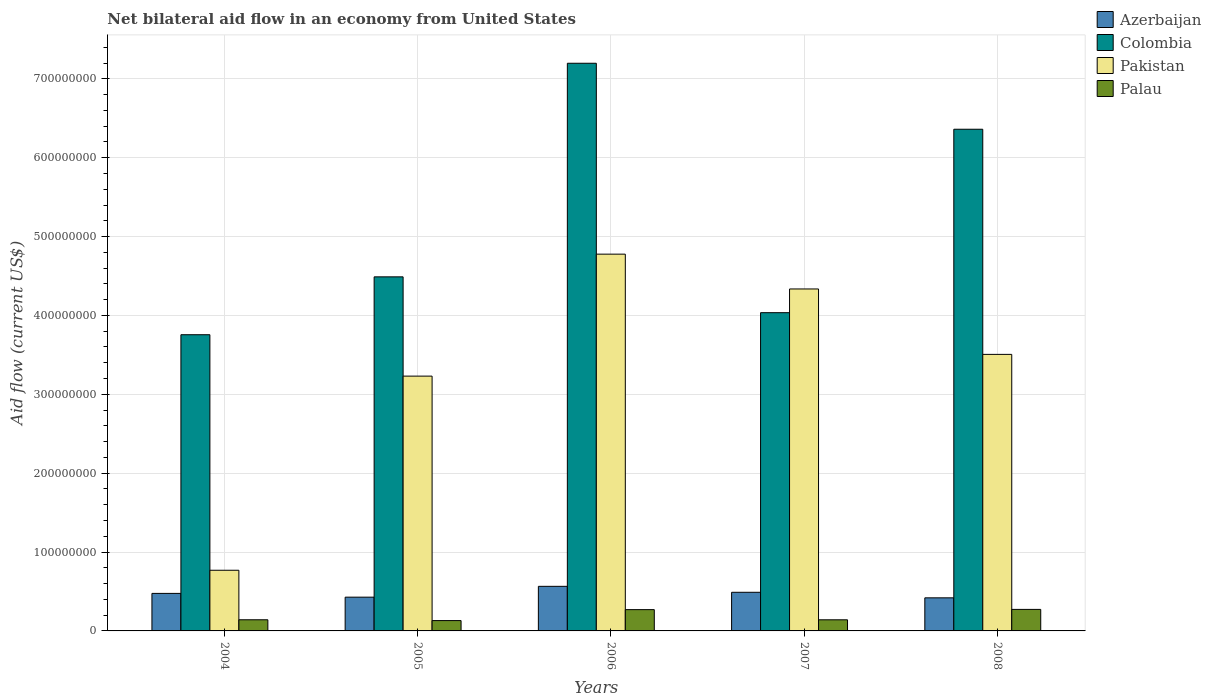How many groups of bars are there?
Your answer should be very brief. 5. How many bars are there on the 5th tick from the left?
Your answer should be compact. 4. How many bars are there on the 2nd tick from the right?
Provide a succinct answer. 4. What is the label of the 1st group of bars from the left?
Provide a short and direct response. 2004. What is the net bilateral aid flow in Colombia in 2004?
Your answer should be compact. 3.76e+08. Across all years, what is the maximum net bilateral aid flow in Palau?
Your answer should be compact. 2.73e+07. Across all years, what is the minimum net bilateral aid flow in Colombia?
Offer a terse response. 3.76e+08. What is the total net bilateral aid flow in Palau in the graph?
Provide a short and direct response. 9.56e+07. What is the difference between the net bilateral aid flow in Pakistan in 2004 and that in 2008?
Your answer should be very brief. -2.74e+08. What is the difference between the net bilateral aid flow in Azerbaijan in 2006 and the net bilateral aid flow in Colombia in 2004?
Provide a short and direct response. -3.19e+08. What is the average net bilateral aid flow in Azerbaijan per year?
Offer a terse response. 4.76e+07. In the year 2004, what is the difference between the net bilateral aid flow in Palau and net bilateral aid flow in Colombia?
Offer a very short reply. -3.61e+08. In how many years, is the net bilateral aid flow in Palau greater than 60000000 US$?
Provide a short and direct response. 0. What is the ratio of the net bilateral aid flow in Palau in 2006 to that in 2008?
Provide a short and direct response. 0.99. Is the net bilateral aid flow in Azerbaijan in 2004 less than that in 2007?
Your response must be concise. Yes. What is the difference between the highest and the second highest net bilateral aid flow in Pakistan?
Your response must be concise. 4.42e+07. What is the difference between the highest and the lowest net bilateral aid flow in Colombia?
Your answer should be very brief. 3.44e+08. In how many years, is the net bilateral aid flow in Pakistan greater than the average net bilateral aid flow in Pakistan taken over all years?
Give a very brief answer. 3. Is the sum of the net bilateral aid flow in Pakistan in 2004 and 2008 greater than the maximum net bilateral aid flow in Palau across all years?
Ensure brevity in your answer.  Yes. What does the 1st bar from the left in 2008 represents?
Ensure brevity in your answer.  Azerbaijan. What does the 4th bar from the right in 2008 represents?
Provide a short and direct response. Azerbaijan. Is it the case that in every year, the sum of the net bilateral aid flow in Palau and net bilateral aid flow in Pakistan is greater than the net bilateral aid flow in Azerbaijan?
Your answer should be very brief. Yes. How many bars are there?
Your answer should be very brief. 20. Are all the bars in the graph horizontal?
Your answer should be compact. No. Does the graph contain any zero values?
Offer a terse response. No. Where does the legend appear in the graph?
Offer a terse response. Top right. How many legend labels are there?
Keep it short and to the point. 4. How are the legend labels stacked?
Your response must be concise. Vertical. What is the title of the graph?
Make the answer very short. Net bilateral aid flow in an economy from United States. Does "Cabo Verde" appear as one of the legend labels in the graph?
Make the answer very short. No. What is the label or title of the Y-axis?
Keep it short and to the point. Aid flow (current US$). What is the Aid flow (current US$) in Azerbaijan in 2004?
Provide a short and direct response. 4.76e+07. What is the Aid flow (current US$) of Colombia in 2004?
Your answer should be very brief. 3.76e+08. What is the Aid flow (current US$) of Pakistan in 2004?
Make the answer very short. 7.69e+07. What is the Aid flow (current US$) of Palau in 2004?
Ensure brevity in your answer.  1.41e+07. What is the Aid flow (current US$) of Azerbaijan in 2005?
Give a very brief answer. 4.28e+07. What is the Aid flow (current US$) in Colombia in 2005?
Your answer should be compact. 4.49e+08. What is the Aid flow (current US$) in Pakistan in 2005?
Provide a short and direct response. 3.23e+08. What is the Aid flow (current US$) in Palau in 2005?
Your answer should be very brief. 1.31e+07. What is the Aid flow (current US$) in Azerbaijan in 2006?
Offer a terse response. 5.65e+07. What is the Aid flow (current US$) of Colombia in 2006?
Make the answer very short. 7.20e+08. What is the Aid flow (current US$) of Pakistan in 2006?
Give a very brief answer. 4.78e+08. What is the Aid flow (current US$) of Palau in 2006?
Your response must be concise. 2.70e+07. What is the Aid flow (current US$) in Azerbaijan in 2007?
Make the answer very short. 4.90e+07. What is the Aid flow (current US$) of Colombia in 2007?
Your response must be concise. 4.04e+08. What is the Aid flow (current US$) of Pakistan in 2007?
Your answer should be very brief. 4.34e+08. What is the Aid flow (current US$) in Palau in 2007?
Offer a terse response. 1.41e+07. What is the Aid flow (current US$) of Azerbaijan in 2008?
Your answer should be very brief. 4.20e+07. What is the Aid flow (current US$) of Colombia in 2008?
Offer a very short reply. 6.36e+08. What is the Aid flow (current US$) in Pakistan in 2008?
Offer a terse response. 3.51e+08. What is the Aid flow (current US$) in Palau in 2008?
Provide a succinct answer. 2.73e+07. Across all years, what is the maximum Aid flow (current US$) of Azerbaijan?
Give a very brief answer. 5.65e+07. Across all years, what is the maximum Aid flow (current US$) of Colombia?
Offer a terse response. 7.20e+08. Across all years, what is the maximum Aid flow (current US$) of Pakistan?
Your answer should be very brief. 4.78e+08. Across all years, what is the maximum Aid flow (current US$) of Palau?
Make the answer very short. 2.73e+07. Across all years, what is the minimum Aid flow (current US$) in Azerbaijan?
Offer a terse response. 4.20e+07. Across all years, what is the minimum Aid flow (current US$) of Colombia?
Give a very brief answer. 3.76e+08. Across all years, what is the minimum Aid flow (current US$) in Pakistan?
Offer a terse response. 7.69e+07. Across all years, what is the minimum Aid flow (current US$) in Palau?
Offer a terse response. 1.31e+07. What is the total Aid flow (current US$) of Azerbaijan in the graph?
Ensure brevity in your answer.  2.38e+08. What is the total Aid flow (current US$) in Colombia in the graph?
Provide a short and direct response. 2.58e+09. What is the total Aid flow (current US$) in Pakistan in the graph?
Keep it short and to the point. 1.66e+09. What is the total Aid flow (current US$) in Palau in the graph?
Provide a short and direct response. 9.56e+07. What is the difference between the Aid flow (current US$) in Azerbaijan in 2004 and that in 2005?
Provide a succinct answer. 4.78e+06. What is the difference between the Aid flow (current US$) of Colombia in 2004 and that in 2005?
Make the answer very short. -7.34e+07. What is the difference between the Aid flow (current US$) in Pakistan in 2004 and that in 2005?
Provide a succinct answer. -2.46e+08. What is the difference between the Aid flow (current US$) in Palau in 2004 and that in 2005?
Offer a very short reply. 1.04e+06. What is the difference between the Aid flow (current US$) of Azerbaijan in 2004 and that in 2006?
Your answer should be compact. -8.96e+06. What is the difference between the Aid flow (current US$) in Colombia in 2004 and that in 2006?
Keep it short and to the point. -3.44e+08. What is the difference between the Aid flow (current US$) of Pakistan in 2004 and that in 2006?
Your answer should be very brief. -4.01e+08. What is the difference between the Aid flow (current US$) of Palau in 2004 and that in 2006?
Offer a terse response. -1.29e+07. What is the difference between the Aid flow (current US$) of Azerbaijan in 2004 and that in 2007?
Keep it short and to the point. -1.40e+06. What is the difference between the Aid flow (current US$) of Colombia in 2004 and that in 2007?
Offer a very short reply. -2.79e+07. What is the difference between the Aid flow (current US$) of Pakistan in 2004 and that in 2007?
Your answer should be very brief. -3.57e+08. What is the difference between the Aid flow (current US$) of Palau in 2004 and that in 2007?
Ensure brevity in your answer.  4.00e+04. What is the difference between the Aid flow (current US$) of Azerbaijan in 2004 and that in 2008?
Your answer should be compact. 5.63e+06. What is the difference between the Aid flow (current US$) in Colombia in 2004 and that in 2008?
Your response must be concise. -2.61e+08. What is the difference between the Aid flow (current US$) in Pakistan in 2004 and that in 2008?
Your response must be concise. -2.74e+08. What is the difference between the Aid flow (current US$) of Palau in 2004 and that in 2008?
Ensure brevity in your answer.  -1.32e+07. What is the difference between the Aid flow (current US$) in Azerbaijan in 2005 and that in 2006?
Provide a succinct answer. -1.37e+07. What is the difference between the Aid flow (current US$) in Colombia in 2005 and that in 2006?
Offer a very short reply. -2.71e+08. What is the difference between the Aid flow (current US$) of Pakistan in 2005 and that in 2006?
Give a very brief answer. -1.55e+08. What is the difference between the Aid flow (current US$) of Palau in 2005 and that in 2006?
Your response must be concise. -1.39e+07. What is the difference between the Aid flow (current US$) in Azerbaijan in 2005 and that in 2007?
Your response must be concise. -6.18e+06. What is the difference between the Aid flow (current US$) of Colombia in 2005 and that in 2007?
Ensure brevity in your answer.  4.54e+07. What is the difference between the Aid flow (current US$) in Pakistan in 2005 and that in 2007?
Ensure brevity in your answer.  -1.10e+08. What is the difference between the Aid flow (current US$) of Azerbaijan in 2005 and that in 2008?
Offer a very short reply. 8.50e+05. What is the difference between the Aid flow (current US$) of Colombia in 2005 and that in 2008?
Your answer should be compact. -1.87e+08. What is the difference between the Aid flow (current US$) of Pakistan in 2005 and that in 2008?
Your answer should be very brief. -2.76e+07. What is the difference between the Aid flow (current US$) of Palau in 2005 and that in 2008?
Provide a short and direct response. -1.42e+07. What is the difference between the Aid flow (current US$) in Azerbaijan in 2006 and that in 2007?
Your answer should be compact. 7.56e+06. What is the difference between the Aid flow (current US$) of Colombia in 2006 and that in 2007?
Your response must be concise. 3.16e+08. What is the difference between the Aid flow (current US$) in Pakistan in 2006 and that in 2007?
Keep it short and to the point. 4.42e+07. What is the difference between the Aid flow (current US$) in Palau in 2006 and that in 2007?
Make the answer very short. 1.29e+07. What is the difference between the Aid flow (current US$) of Azerbaijan in 2006 and that in 2008?
Offer a terse response. 1.46e+07. What is the difference between the Aid flow (current US$) of Colombia in 2006 and that in 2008?
Your response must be concise. 8.37e+07. What is the difference between the Aid flow (current US$) of Pakistan in 2006 and that in 2008?
Your response must be concise. 1.27e+08. What is the difference between the Aid flow (current US$) of Palau in 2006 and that in 2008?
Provide a short and direct response. -2.90e+05. What is the difference between the Aid flow (current US$) of Azerbaijan in 2007 and that in 2008?
Offer a very short reply. 7.03e+06. What is the difference between the Aid flow (current US$) of Colombia in 2007 and that in 2008?
Provide a short and direct response. -2.33e+08. What is the difference between the Aid flow (current US$) of Pakistan in 2007 and that in 2008?
Provide a short and direct response. 8.29e+07. What is the difference between the Aid flow (current US$) of Palau in 2007 and that in 2008?
Give a very brief answer. -1.32e+07. What is the difference between the Aid flow (current US$) in Azerbaijan in 2004 and the Aid flow (current US$) in Colombia in 2005?
Provide a succinct answer. -4.01e+08. What is the difference between the Aid flow (current US$) in Azerbaijan in 2004 and the Aid flow (current US$) in Pakistan in 2005?
Keep it short and to the point. -2.75e+08. What is the difference between the Aid flow (current US$) in Azerbaijan in 2004 and the Aid flow (current US$) in Palau in 2005?
Offer a terse response. 3.45e+07. What is the difference between the Aid flow (current US$) in Colombia in 2004 and the Aid flow (current US$) in Pakistan in 2005?
Provide a short and direct response. 5.25e+07. What is the difference between the Aid flow (current US$) in Colombia in 2004 and the Aid flow (current US$) in Palau in 2005?
Offer a very short reply. 3.62e+08. What is the difference between the Aid flow (current US$) in Pakistan in 2004 and the Aid flow (current US$) in Palau in 2005?
Ensure brevity in your answer.  6.38e+07. What is the difference between the Aid flow (current US$) of Azerbaijan in 2004 and the Aid flow (current US$) of Colombia in 2006?
Your answer should be compact. -6.72e+08. What is the difference between the Aid flow (current US$) of Azerbaijan in 2004 and the Aid flow (current US$) of Pakistan in 2006?
Provide a short and direct response. -4.30e+08. What is the difference between the Aid flow (current US$) in Azerbaijan in 2004 and the Aid flow (current US$) in Palau in 2006?
Provide a short and direct response. 2.06e+07. What is the difference between the Aid flow (current US$) of Colombia in 2004 and the Aid flow (current US$) of Pakistan in 2006?
Provide a succinct answer. -1.02e+08. What is the difference between the Aid flow (current US$) of Colombia in 2004 and the Aid flow (current US$) of Palau in 2006?
Keep it short and to the point. 3.49e+08. What is the difference between the Aid flow (current US$) in Pakistan in 2004 and the Aid flow (current US$) in Palau in 2006?
Your answer should be very brief. 4.99e+07. What is the difference between the Aid flow (current US$) of Azerbaijan in 2004 and the Aid flow (current US$) of Colombia in 2007?
Your answer should be compact. -3.56e+08. What is the difference between the Aid flow (current US$) in Azerbaijan in 2004 and the Aid flow (current US$) in Pakistan in 2007?
Keep it short and to the point. -3.86e+08. What is the difference between the Aid flow (current US$) of Azerbaijan in 2004 and the Aid flow (current US$) of Palau in 2007?
Provide a short and direct response. 3.35e+07. What is the difference between the Aid flow (current US$) of Colombia in 2004 and the Aid flow (current US$) of Pakistan in 2007?
Provide a short and direct response. -5.80e+07. What is the difference between the Aid flow (current US$) of Colombia in 2004 and the Aid flow (current US$) of Palau in 2007?
Your response must be concise. 3.61e+08. What is the difference between the Aid flow (current US$) in Pakistan in 2004 and the Aid flow (current US$) in Palau in 2007?
Your answer should be compact. 6.28e+07. What is the difference between the Aid flow (current US$) in Azerbaijan in 2004 and the Aid flow (current US$) in Colombia in 2008?
Ensure brevity in your answer.  -5.89e+08. What is the difference between the Aid flow (current US$) of Azerbaijan in 2004 and the Aid flow (current US$) of Pakistan in 2008?
Give a very brief answer. -3.03e+08. What is the difference between the Aid flow (current US$) of Azerbaijan in 2004 and the Aid flow (current US$) of Palau in 2008?
Give a very brief answer. 2.03e+07. What is the difference between the Aid flow (current US$) of Colombia in 2004 and the Aid flow (current US$) of Pakistan in 2008?
Make the answer very short. 2.49e+07. What is the difference between the Aid flow (current US$) in Colombia in 2004 and the Aid flow (current US$) in Palau in 2008?
Offer a terse response. 3.48e+08. What is the difference between the Aid flow (current US$) in Pakistan in 2004 and the Aid flow (current US$) in Palau in 2008?
Ensure brevity in your answer.  4.96e+07. What is the difference between the Aid flow (current US$) in Azerbaijan in 2005 and the Aid flow (current US$) in Colombia in 2006?
Provide a short and direct response. -6.77e+08. What is the difference between the Aid flow (current US$) of Azerbaijan in 2005 and the Aid flow (current US$) of Pakistan in 2006?
Provide a short and direct response. -4.35e+08. What is the difference between the Aid flow (current US$) in Azerbaijan in 2005 and the Aid flow (current US$) in Palau in 2006?
Provide a short and direct response. 1.58e+07. What is the difference between the Aid flow (current US$) in Colombia in 2005 and the Aid flow (current US$) in Pakistan in 2006?
Offer a terse response. -2.88e+07. What is the difference between the Aid flow (current US$) in Colombia in 2005 and the Aid flow (current US$) in Palau in 2006?
Ensure brevity in your answer.  4.22e+08. What is the difference between the Aid flow (current US$) in Pakistan in 2005 and the Aid flow (current US$) in Palau in 2006?
Offer a terse response. 2.96e+08. What is the difference between the Aid flow (current US$) of Azerbaijan in 2005 and the Aid flow (current US$) of Colombia in 2007?
Keep it short and to the point. -3.61e+08. What is the difference between the Aid flow (current US$) of Azerbaijan in 2005 and the Aid flow (current US$) of Pakistan in 2007?
Make the answer very short. -3.91e+08. What is the difference between the Aid flow (current US$) of Azerbaijan in 2005 and the Aid flow (current US$) of Palau in 2007?
Your answer should be compact. 2.87e+07. What is the difference between the Aid flow (current US$) of Colombia in 2005 and the Aid flow (current US$) of Pakistan in 2007?
Your response must be concise. 1.54e+07. What is the difference between the Aid flow (current US$) of Colombia in 2005 and the Aid flow (current US$) of Palau in 2007?
Your response must be concise. 4.35e+08. What is the difference between the Aid flow (current US$) in Pakistan in 2005 and the Aid flow (current US$) in Palau in 2007?
Ensure brevity in your answer.  3.09e+08. What is the difference between the Aid flow (current US$) of Azerbaijan in 2005 and the Aid flow (current US$) of Colombia in 2008?
Ensure brevity in your answer.  -5.93e+08. What is the difference between the Aid flow (current US$) in Azerbaijan in 2005 and the Aid flow (current US$) in Pakistan in 2008?
Provide a short and direct response. -3.08e+08. What is the difference between the Aid flow (current US$) in Azerbaijan in 2005 and the Aid flow (current US$) in Palau in 2008?
Ensure brevity in your answer.  1.55e+07. What is the difference between the Aid flow (current US$) of Colombia in 2005 and the Aid flow (current US$) of Pakistan in 2008?
Make the answer very short. 9.83e+07. What is the difference between the Aid flow (current US$) in Colombia in 2005 and the Aid flow (current US$) in Palau in 2008?
Your answer should be compact. 4.22e+08. What is the difference between the Aid flow (current US$) in Pakistan in 2005 and the Aid flow (current US$) in Palau in 2008?
Offer a terse response. 2.96e+08. What is the difference between the Aid flow (current US$) in Azerbaijan in 2006 and the Aid flow (current US$) in Colombia in 2007?
Make the answer very short. -3.47e+08. What is the difference between the Aid flow (current US$) of Azerbaijan in 2006 and the Aid flow (current US$) of Pakistan in 2007?
Keep it short and to the point. -3.77e+08. What is the difference between the Aid flow (current US$) of Azerbaijan in 2006 and the Aid flow (current US$) of Palau in 2007?
Your response must be concise. 4.24e+07. What is the difference between the Aid flow (current US$) in Colombia in 2006 and the Aid flow (current US$) in Pakistan in 2007?
Provide a succinct answer. 2.86e+08. What is the difference between the Aid flow (current US$) in Colombia in 2006 and the Aid flow (current US$) in Palau in 2007?
Provide a short and direct response. 7.06e+08. What is the difference between the Aid flow (current US$) of Pakistan in 2006 and the Aid flow (current US$) of Palau in 2007?
Your answer should be compact. 4.64e+08. What is the difference between the Aid flow (current US$) of Azerbaijan in 2006 and the Aid flow (current US$) of Colombia in 2008?
Keep it short and to the point. -5.80e+08. What is the difference between the Aid flow (current US$) of Azerbaijan in 2006 and the Aid flow (current US$) of Pakistan in 2008?
Your response must be concise. -2.94e+08. What is the difference between the Aid flow (current US$) of Azerbaijan in 2006 and the Aid flow (current US$) of Palau in 2008?
Give a very brief answer. 2.92e+07. What is the difference between the Aid flow (current US$) of Colombia in 2006 and the Aid flow (current US$) of Pakistan in 2008?
Make the answer very short. 3.69e+08. What is the difference between the Aid flow (current US$) in Colombia in 2006 and the Aid flow (current US$) in Palau in 2008?
Provide a short and direct response. 6.92e+08. What is the difference between the Aid flow (current US$) in Pakistan in 2006 and the Aid flow (current US$) in Palau in 2008?
Make the answer very short. 4.50e+08. What is the difference between the Aid flow (current US$) in Azerbaijan in 2007 and the Aid flow (current US$) in Colombia in 2008?
Your response must be concise. -5.87e+08. What is the difference between the Aid flow (current US$) of Azerbaijan in 2007 and the Aid flow (current US$) of Pakistan in 2008?
Ensure brevity in your answer.  -3.02e+08. What is the difference between the Aid flow (current US$) of Azerbaijan in 2007 and the Aid flow (current US$) of Palau in 2008?
Your answer should be compact. 2.17e+07. What is the difference between the Aid flow (current US$) of Colombia in 2007 and the Aid flow (current US$) of Pakistan in 2008?
Your answer should be very brief. 5.29e+07. What is the difference between the Aid flow (current US$) of Colombia in 2007 and the Aid flow (current US$) of Palau in 2008?
Offer a very short reply. 3.76e+08. What is the difference between the Aid flow (current US$) in Pakistan in 2007 and the Aid flow (current US$) in Palau in 2008?
Keep it short and to the point. 4.06e+08. What is the average Aid flow (current US$) in Azerbaijan per year?
Provide a succinct answer. 4.76e+07. What is the average Aid flow (current US$) of Colombia per year?
Offer a terse response. 5.17e+08. What is the average Aid flow (current US$) in Pakistan per year?
Ensure brevity in your answer.  3.32e+08. What is the average Aid flow (current US$) of Palau per year?
Your answer should be very brief. 1.91e+07. In the year 2004, what is the difference between the Aid flow (current US$) of Azerbaijan and Aid flow (current US$) of Colombia?
Ensure brevity in your answer.  -3.28e+08. In the year 2004, what is the difference between the Aid flow (current US$) in Azerbaijan and Aid flow (current US$) in Pakistan?
Your answer should be compact. -2.93e+07. In the year 2004, what is the difference between the Aid flow (current US$) of Azerbaijan and Aid flow (current US$) of Palau?
Provide a short and direct response. 3.34e+07. In the year 2004, what is the difference between the Aid flow (current US$) of Colombia and Aid flow (current US$) of Pakistan?
Offer a very short reply. 2.99e+08. In the year 2004, what is the difference between the Aid flow (current US$) in Colombia and Aid flow (current US$) in Palau?
Offer a very short reply. 3.61e+08. In the year 2004, what is the difference between the Aid flow (current US$) of Pakistan and Aid flow (current US$) of Palau?
Your answer should be compact. 6.28e+07. In the year 2005, what is the difference between the Aid flow (current US$) of Azerbaijan and Aid flow (current US$) of Colombia?
Your answer should be very brief. -4.06e+08. In the year 2005, what is the difference between the Aid flow (current US$) in Azerbaijan and Aid flow (current US$) in Pakistan?
Your answer should be compact. -2.80e+08. In the year 2005, what is the difference between the Aid flow (current US$) of Azerbaijan and Aid flow (current US$) of Palau?
Provide a short and direct response. 2.97e+07. In the year 2005, what is the difference between the Aid flow (current US$) in Colombia and Aid flow (current US$) in Pakistan?
Your response must be concise. 1.26e+08. In the year 2005, what is the difference between the Aid flow (current US$) in Colombia and Aid flow (current US$) in Palau?
Your answer should be very brief. 4.36e+08. In the year 2005, what is the difference between the Aid flow (current US$) of Pakistan and Aid flow (current US$) of Palau?
Keep it short and to the point. 3.10e+08. In the year 2006, what is the difference between the Aid flow (current US$) in Azerbaijan and Aid flow (current US$) in Colombia?
Make the answer very short. -6.63e+08. In the year 2006, what is the difference between the Aid flow (current US$) of Azerbaijan and Aid flow (current US$) of Pakistan?
Ensure brevity in your answer.  -4.21e+08. In the year 2006, what is the difference between the Aid flow (current US$) of Azerbaijan and Aid flow (current US$) of Palau?
Your response must be concise. 2.95e+07. In the year 2006, what is the difference between the Aid flow (current US$) of Colombia and Aid flow (current US$) of Pakistan?
Offer a terse response. 2.42e+08. In the year 2006, what is the difference between the Aid flow (current US$) in Colombia and Aid flow (current US$) in Palau?
Your response must be concise. 6.93e+08. In the year 2006, what is the difference between the Aid flow (current US$) in Pakistan and Aid flow (current US$) in Palau?
Keep it short and to the point. 4.51e+08. In the year 2007, what is the difference between the Aid flow (current US$) in Azerbaijan and Aid flow (current US$) in Colombia?
Your response must be concise. -3.55e+08. In the year 2007, what is the difference between the Aid flow (current US$) of Azerbaijan and Aid flow (current US$) of Pakistan?
Your answer should be compact. -3.85e+08. In the year 2007, what is the difference between the Aid flow (current US$) of Azerbaijan and Aid flow (current US$) of Palau?
Provide a short and direct response. 3.49e+07. In the year 2007, what is the difference between the Aid flow (current US$) in Colombia and Aid flow (current US$) in Pakistan?
Keep it short and to the point. -3.01e+07. In the year 2007, what is the difference between the Aid flow (current US$) of Colombia and Aid flow (current US$) of Palau?
Offer a terse response. 3.89e+08. In the year 2007, what is the difference between the Aid flow (current US$) of Pakistan and Aid flow (current US$) of Palau?
Ensure brevity in your answer.  4.19e+08. In the year 2008, what is the difference between the Aid flow (current US$) in Azerbaijan and Aid flow (current US$) in Colombia?
Provide a succinct answer. -5.94e+08. In the year 2008, what is the difference between the Aid flow (current US$) in Azerbaijan and Aid flow (current US$) in Pakistan?
Make the answer very short. -3.09e+08. In the year 2008, what is the difference between the Aid flow (current US$) in Azerbaijan and Aid flow (current US$) in Palau?
Offer a terse response. 1.47e+07. In the year 2008, what is the difference between the Aid flow (current US$) of Colombia and Aid flow (current US$) of Pakistan?
Provide a short and direct response. 2.85e+08. In the year 2008, what is the difference between the Aid flow (current US$) of Colombia and Aid flow (current US$) of Palau?
Offer a very short reply. 6.09e+08. In the year 2008, what is the difference between the Aid flow (current US$) in Pakistan and Aid flow (current US$) in Palau?
Give a very brief answer. 3.23e+08. What is the ratio of the Aid flow (current US$) in Azerbaijan in 2004 to that in 2005?
Make the answer very short. 1.11. What is the ratio of the Aid flow (current US$) of Colombia in 2004 to that in 2005?
Give a very brief answer. 0.84. What is the ratio of the Aid flow (current US$) in Pakistan in 2004 to that in 2005?
Provide a short and direct response. 0.24. What is the ratio of the Aid flow (current US$) in Palau in 2004 to that in 2005?
Ensure brevity in your answer.  1.08. What is the ratio of the Aid flow (current US$) in Azerbaijan in 2004 to that in 2006?
Provide a succinct answer. 0.84. What is the ratio of the Aid flow (current US$) of Colombia in 2004 to that in 2006?
Your answer should be compact. 0.52. What is the ratio of the Aid flow (current US$) of Pakistan in 2004 to that in 2006?
Your answer should be compact. 0.16. What is the ratio of the Aid flow (current US$) in Palau in 2004 to that in 2006?
Offer a very short reply. 0.52. What is the ratio of the Aid flow (current US$) of Azerbaijan in 2004 to that in 2007?
Make the answer very short. 0.97. What is the ratio of the Aid flow (current US$) in Colombia in 2004 to that in 2007?
Offer a very short reply. 0.93. What is the ratio of the Aid flow (current US$) in Pakistan in 2004 to that in 2007?
Offer a terse response. 0.18. What is the ratio of the Aid flow (current US$) in Azerbaijan in 2004 to that in 2008?
Your answer should be compact. 1.13. What is the ratio of the Aid flow (current US$) of Colombia in 2004 to that in 2008?
Give a very brief answer. 0.59. What is the ratio of the Aid flow (current US$) in Pakistan in 2004 to that in 2008?
Ensure brevity in your answer.  0.22. What is the ratio of the Aid flow (current US$) in Palau in 2004 to that in 2008?
Make the answer very short. 0.52. What is the ratio of the Aid flow (current US$) of Azerbaijan in 2005 to that in 2006?
Keep it short and to the point. 0.76. What is the ratio of the Aid flow (current US$) of Colombia in 2005 to that in 2006?
Your answer should be compact. 0.62. What is the ratio of the Aid flow (current US$) in Pakistan in 2005 to that in 2006?
Offer a terse response. 0.68. What is the ratio of the Aid flow (current US$) of Palau in 2005 to that in 2006?
Keep it short and to the point. 0.49. What is the ratio of the Aid flow (current US$) of Azerbaijan in 2005 to that in 2007?
Your answer should be very brief. 0.87. What is the ratio of the Aid flow (current US$) in Colombia in 2005 to that in 2007?
Your response must be concise. 1.11. What is the ratio of the Aid flow (current US$) in Pakistan in 2005 to that in 2007?
Provide a short and direct response. 0.75. What is the ratio of the Aid flow (current US$) in Palau in 2005 to that in 2007?
Ensure brevity in your answer.  0.93. What is the ratio of the Aid flow (current US$) of Azerbaijan in 2005 to that in 2008?
Ensure brevity in your answer.  1.02. What is the ratio of the Aid flow (current US$) in Colombia in 2005 to that in 2008?
Provide a succinct answer. 0.71. What is the ratio of the Aid flow (current US$) in Pakistan in 2005 to that in 2008?
Provide a short and direct response. 0.92. What is the ratio of the Aid flow (current US$) in Palau in 2005 to that in 2008?
Provide a short and direct response. 0.48. What is the ratio of the Aid flow (current US$) in Azerbaijan in 2006 to that in 2007?
Keep it short and to the point. 1.15. What is the ratio of the Aid flow (current US$) of Colombia in 2006 to that in 2007?
Your response must be concise. 1.78. What is the ratio of the Aid flow (current US$) of Pakistan in 2006 to that in 2007?
Your answer should be compact. 1.1. What is the ratio of the Aid flow (current US$) of Palau in 2006 to that in 2007?
Your answer should be very brief. 1.91. What is the ratio of the Aid flow (current US$) of Azerbaijan in 2006 to that in 2008?
Make the answer very short. 1.35. What is the ratio of the Aid flow (current US$) of Colombia in 2006 to that in 2008?
Offer a terse response. 1.13. What is the ratio of the Aid flow (current US$) of Pakistan in 2006 to that in 2008?
Offer a terse response. 1.36. What is the ratio of the Aid flow (current US$) in Azerbaijan in 2007 to that in 2008?
Keep it short and to the point. 1.17. What is the ratio of the Aid flow (current US$) in Colombia in 2007 to that in 2008?
Offer a terse response. 0.63. What is the ratio of the Aid flow (current US$) in Pakistan in 2007 to that in 2008?
Your answer should be very brief. 1.24. What is the ratio of the Aid flow (current US$) in Palau in 2007 to that in 2008?
Keep it short and to the point. 0.52. What is the difference between the highest and the second highest Aid flow (current US$) in Azerbaijan?
Make the answer very short. 7.56e+06. What is the difference between the highest and the second highest Aid flow (current US$) in Colombia?
Provide a short and direct response. 8.37e+07. What is the difference between the highest and the second highest Aid flow (current US$) in Pakistan?
Keep it short and to the point. 4.42e+07. What is the difference between the highest and the lowest Aid flow (current US$) in Azerbaijan?
Keep it short and to the point. 1.46e+07. What is the difference between the highest and the lowest Aid flow (current US$) in Colombia?
Your answer should be very brief. 3.44e+08. What is the difference between the highest and the lowest Aid flow (current US$) of Pakistan?
Your answer should be very brief. 4.01e+08. What is the difference between the highest and the lowest Aid flow (current US$) in Palau?
Offer a terse response. 1.42e+07. 